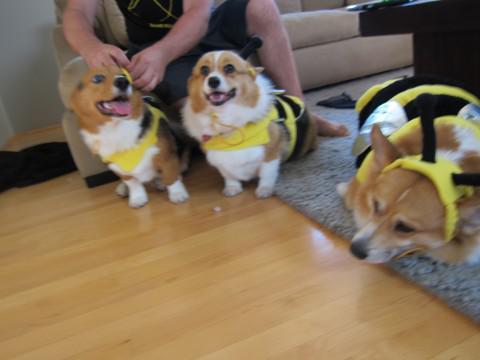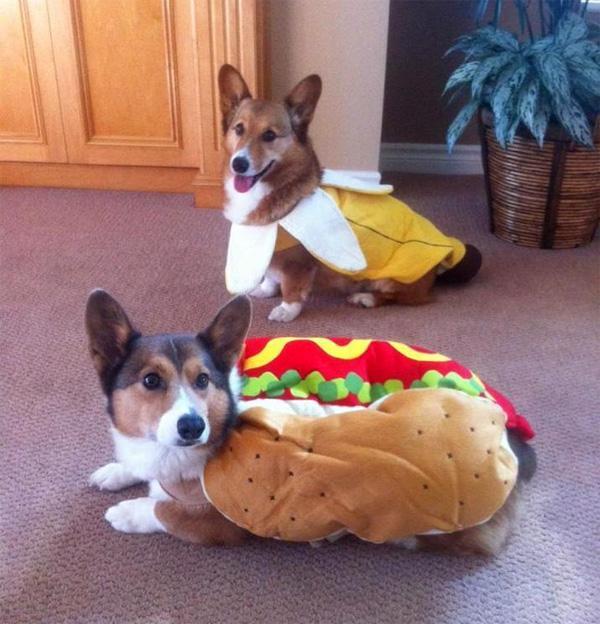The first image is the image on the left, the second image is the image on the right. For the images displayed, is the sentence "There is two dogs in the right image." factually correct? Answer yes or no. Yes. The first image is the image on the left, the second image is the image on the right. Given the left and right images, does the statement "All dogs are wearing costumes, and at least three dogs are wearing black-and-yellow bee costumes." hold true? Answer yes or no. Yes. 